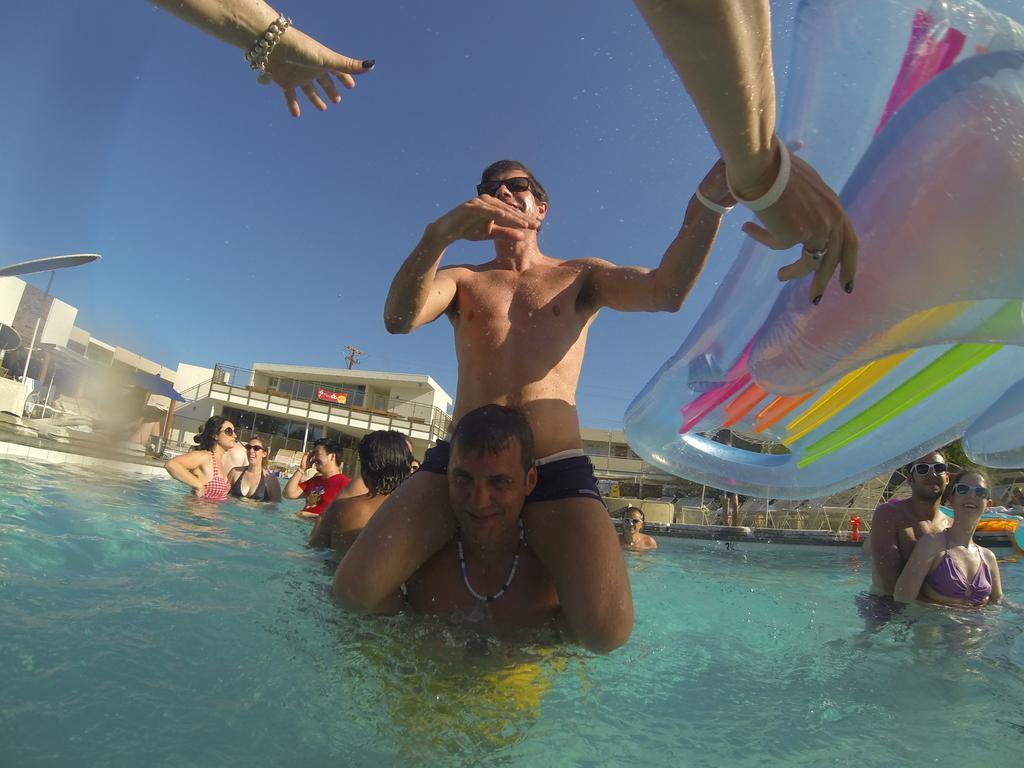Could you give a brief overview of what you see in this image? This image is taken outdoors. At the top of the image there is the sky. In the background there are a few buildings. There is a railing and there are a few pillars. There are a few empty chairs and tables. A few people are standing in the pool. At the bottom of the image there is a pool with water. In the middle of the image two men are playing in the pool. On the right side of the image a man and a woman are swimming in the pool and there are few floating tubes in the pool. 